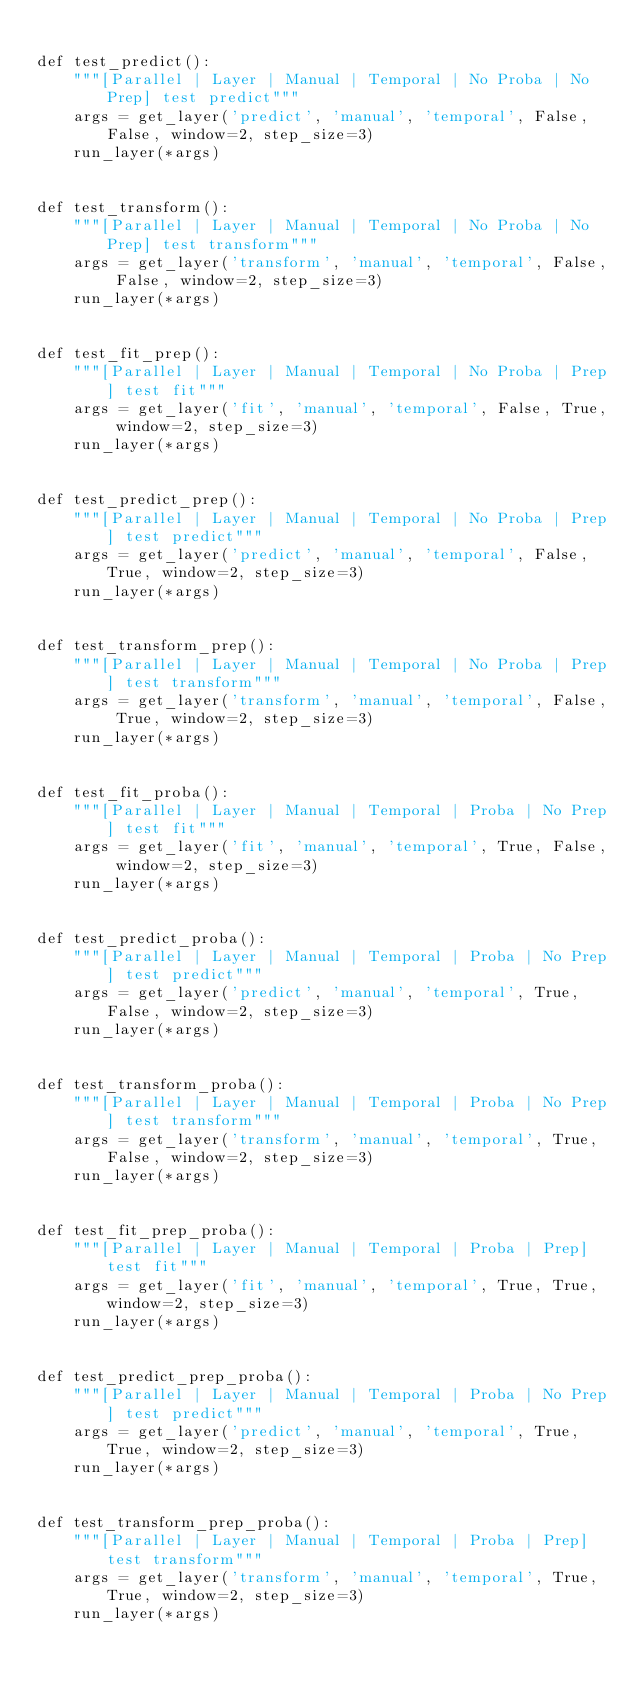<code> <loc_0><loc_0><loc_500><loc_500><_Python_>
def test_predict():
    """[Parallel | Layer | Manual | Temporal | No Proba | No Prep] test predict"""
    args = get_layer('predict', 'manual', 'temporal', False, False, window=2, step_size=3)
    run_layer(*args)


def test_transform():
    """[Parallel | Layer | Manual | Temporal | No Proba | No Prep] test transform"""
    args = get_layer('transform', 'manual', 'temporal', False, False, window=2, step_size=3)
    run_layer(*args)


def test_fit_prep():
    """[Parallel | Layer | Manual | Temporal | No Proba | Prep] test fit"""
    args = get_layer('fit', 'manual', 'temporal', False, True, window=2, step_size=3)
    run_layer(*args)


def test_predict_prep():
    """[Parallel | Layer | Manual | Temporal | No Proba | Prep] test predict"""
    args = get_layer('predict', 'manual', 'temporal', False, True, window=2, step_size=3)
    run_layer(*args)


def test_transform_prep():
    """[Parallel | Layer | Manual | Temporal | No Proba | Prep] test transform"""
    args = get_layer('transform', 'manual', 'temporal', False, True, window=2, step_size=3)
    run_layer(*args)


def test_fit_proba():
    """[Parallel | Layer | Manual | Temporal | Proba | No Prep] test fit"""
    args = get_layer('fit', 'manual', 'temporal', True, False, window=2, step_size=3)
    run_layer(*args)


def test_predict_proba():
    """[Parallel | Layer | Manual | Temporal | Proba | No Prep] test predict"""
    args = get_layer('predict', 'manual', 'temporal', True, False, window=2, step_size=3)
    run_layer(*args)


def test_transform_proba():
    """[Parallel | Layer | Manual | Temporal | Proba | No Prep] test transform"""
    args = get_layer('transform', 'manual', 'temporal', True, False, window=2, step_size=3)
    run_layer(*args)


def test_fit_prep_proba():
    """[Parallel | Layer | Manual | Temporal | Proba | Prep] test fit"""
    args = get_layer('fit', 'manual', 'temporal', True, True, window=2, step_size=3)
    run_layer(*args)


def test_predict_prep_proba():
    """[Parallel | Layer | Manual | Temporal | Proba | No Prep] test predict"""
    args = get_layer('predict', 'manual', 'temporal', True, True, window=2, step_size=3)
    run_layer(*args)


def test_transform_prep_proba():
    """[Parallel | Layer | Manual | Temporal | Proba | Prep] test transform"""
    args = get_layer('transform', 'manual', 'temporal', True, True, window=2, step_size=3)
    run_layer(*args)
</code> 